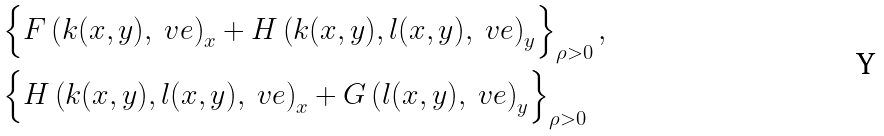Convert formula to latex. <formula><loc_0><loc_0><loc_500><loc_500>& \left \{ F \left ( k ( x , y ) , \ v e \right ) _ { x } + H \left ( k ( x , y ) , l ( x , y ) , \ v e \right ) _ { y } \right \} _ { \rho > 0 } , \\ & \left \{ H \left ( k ( x , y ) , l ( x , y ) , \ v e \right ) _ { x } + G \left ( l ( x , y ) , \ v e \right ) _ { y } \right \} _ { \rho > 0 }</formula> 